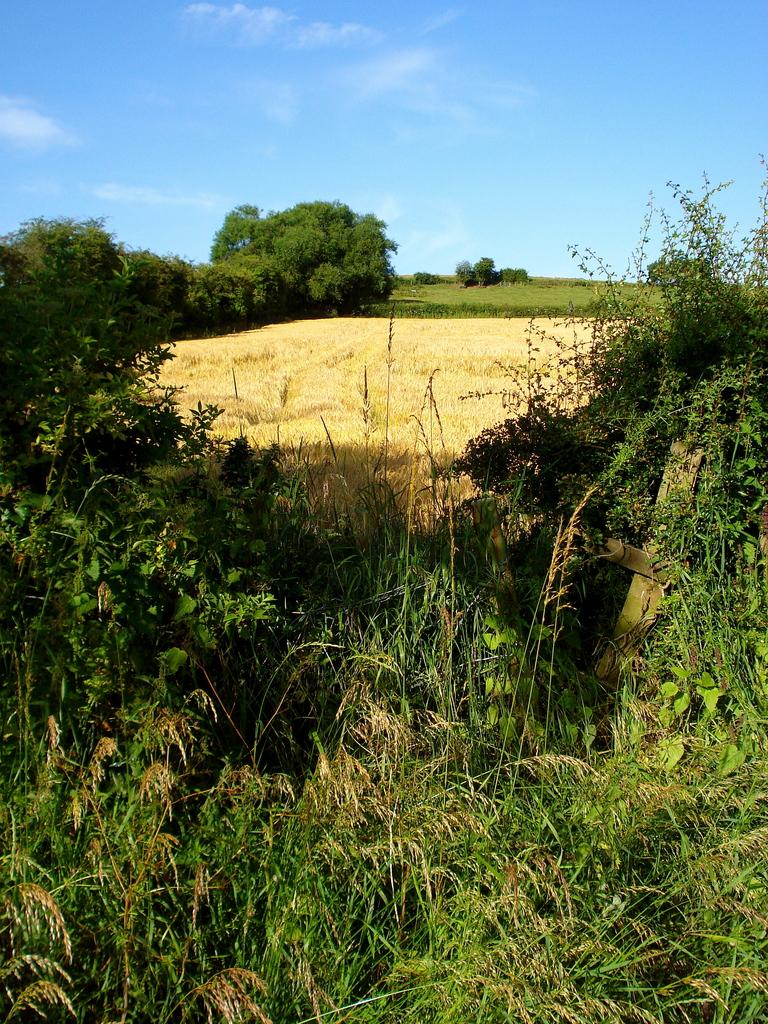What type of vegetation is present at the bottom of the image? There are plants, grass, and trees at the bottom of the image. What can be seen in the sky at the top of the image? The sky is visible at the top of the image, and there are clouds in the sky. What riddle is being solved by the trees at the bottom of the image? There is no riddle being solved by the trees in the image; they are simply depicted as part of the natural landscape. 